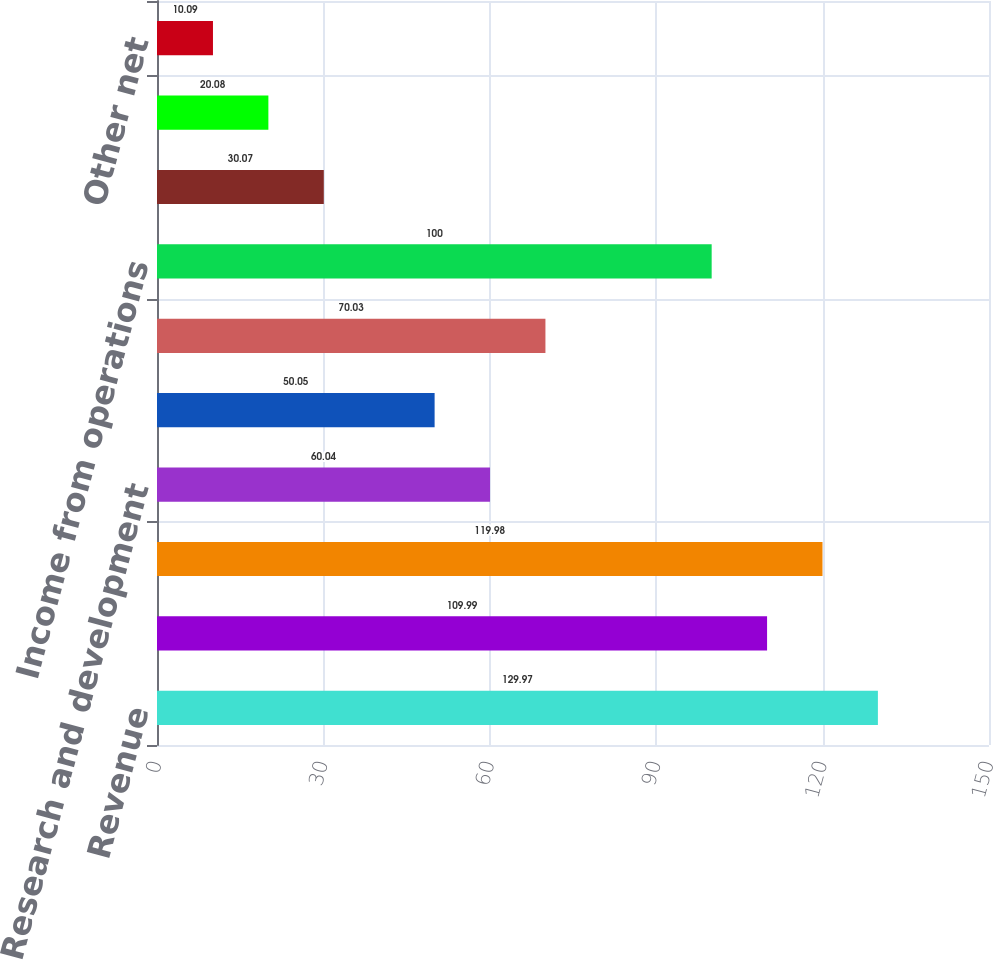Convert chart to OTSL. <chart><loc_0><loc_0><loc_500><loc_500><bar_chart><fcel>Revenue<fcel>Cost of revenue<fcel>Gross profit<fcel>Research and development<fcel>Sales general and<fcel>Total operating expenses<fcel>Income from operations<fcel>Interest income<fcel>Interest expense<fcel>Other net<nl><fcel>129.97<fcel>109.99<fcel>119.98<fcel>60.04<fcel>50.05<fcel>70.03<fcel>100<fcel>30.07<fcel>20.08<fcel>10.09<nl></chart> 